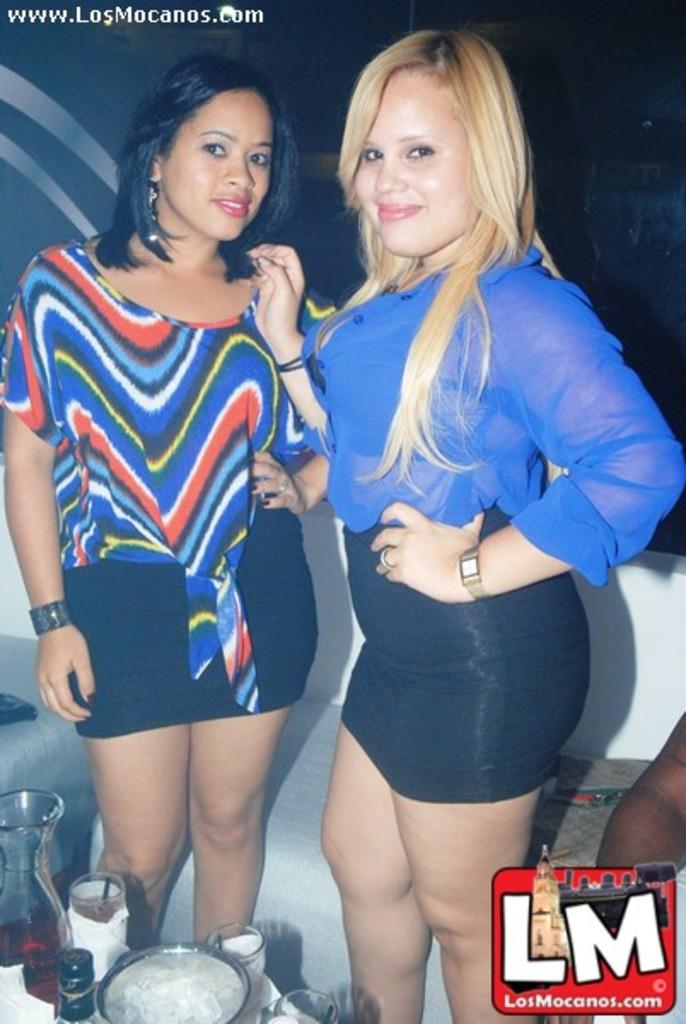<image>
Present a compact description of the photo's key features. Two girls pose for a picture next to the letters LM 